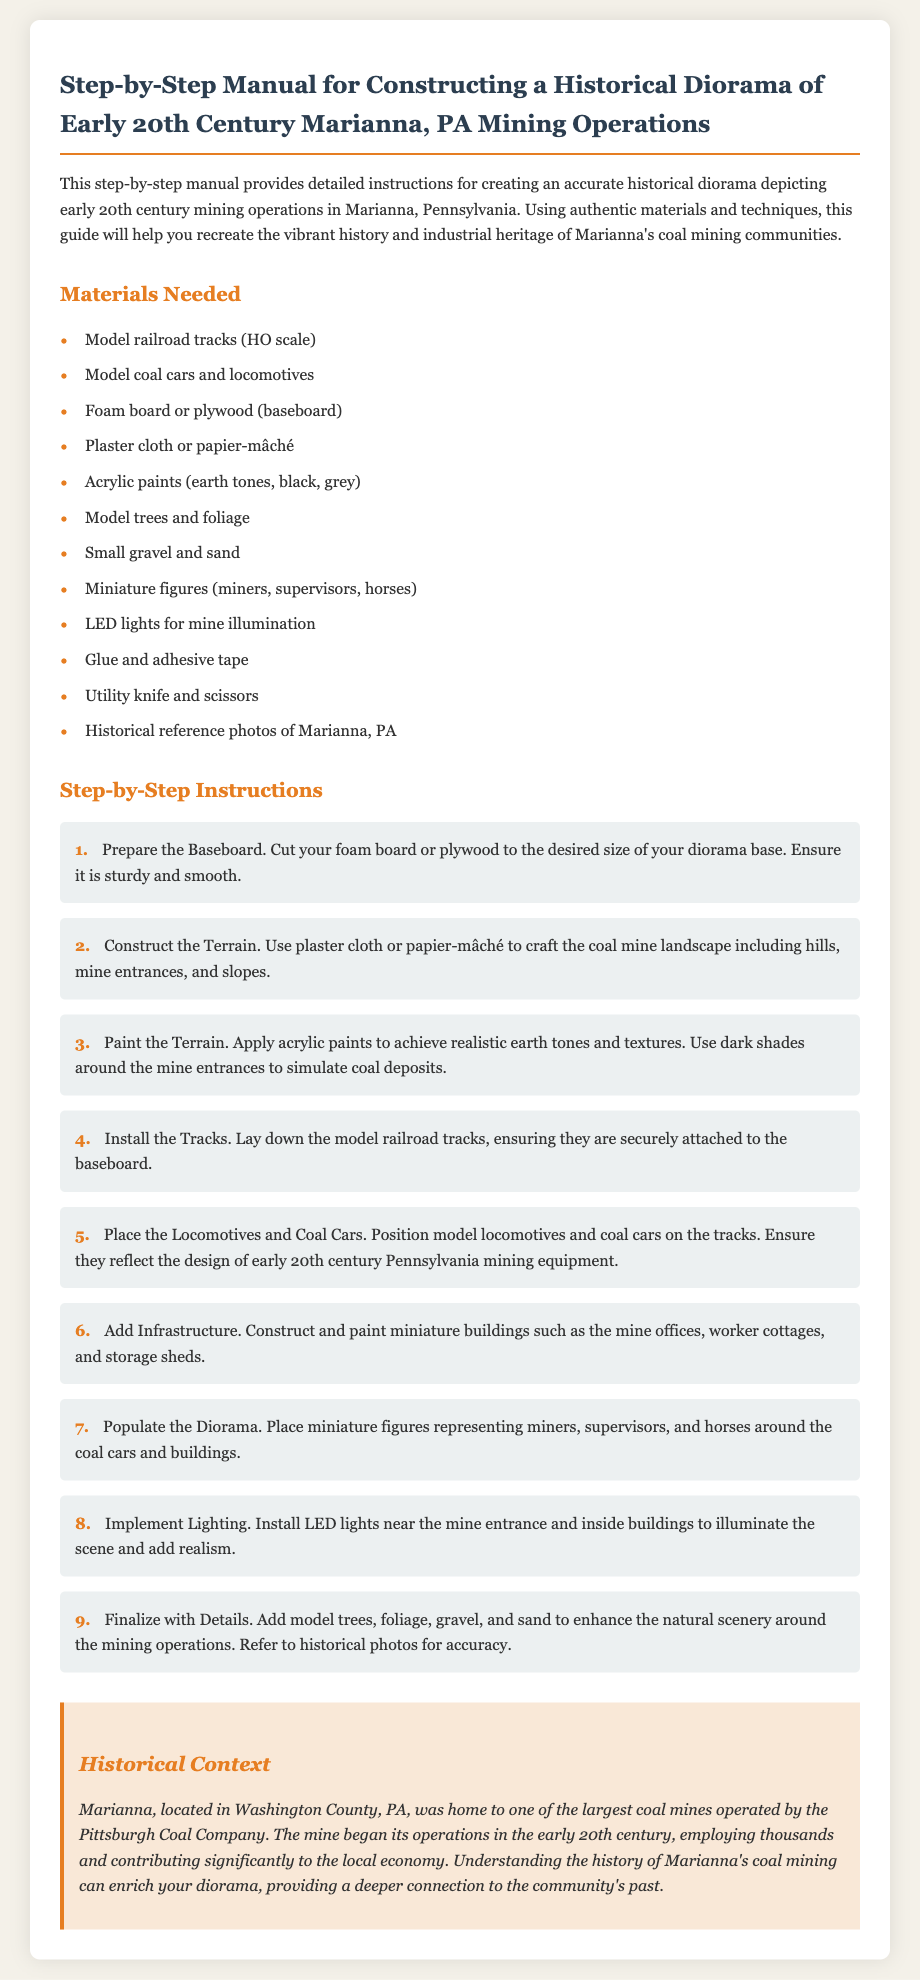What is the title of the document? The title is mentioned at the beginning and describes the content of the manual for constructing a diorama.
Answer: Step-by-Step Manual for Constructing a Historical Diorama of Early 20th Century Marianna, PA Mining Operations What materials are needed for the diorama? The document lists several materials under the "Materials Needed" section.
Answer: Model railroad tracks (HO scale), model coal cars and locomotives, foam board or plywood, plaster cloth or papier-mâché, acrylic paints, model trees, gravel, miniature figures, LED lights, glue, utility knife, scissors, historical reference photos How many steps are included in the instructions? The document lists a series of steps for constructing the diorama.
Answer: 9 What is the name of the coal company mentioned? The document provides historical context and names the company that operated the mine in Marianna.
Answer: Pittsburgh Coal Company What should be done in step 3 of the instructions? The step-by-step sections detail what to do in each phase of constructing the diorama.
Answer: Paint the Terrain What color palette is suggested for the terrain? The document specifies the types of colors to be used in painting the terrain.
Answer: Earth tones, black, grey What is the purpose of the LED lights in the diorama? The document explains the function of installing LED lights in the context of the diorama.
Answer: To illuminate the scene and add realism Where is Marianna located? The historical context section provides geographical information about Marianna.
Answer: Washington County, PA 